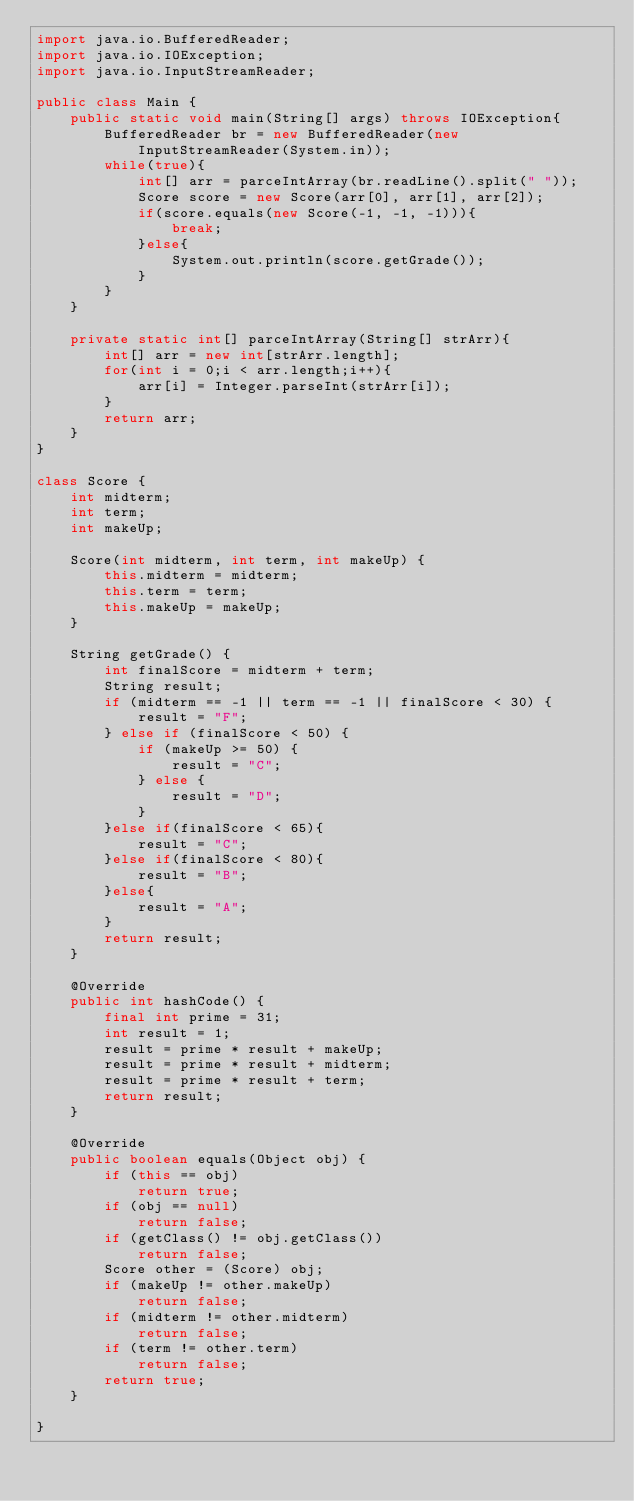<code> <loc_0><loc_0><loc_500><loc_500><_Java_>import java.io.BufferedReader;
import java.io.IOException;
import java.io.InputStreamReader;

public class Main {
	public static void main(String[] args) throws IOException{
		BufferedReader br = new BufferedReader(new InputStreamReader(System.in));
		while(true){
			int[] arr = parceIntArray(br.readLine().split(" "));
			Score score = new Score(arr[0], arr[1], arr[2]);
			if(score.equals(new Score(-1, -1, -1))){
				break;
			}else{
				System.out.println(score.getGrade());
			}
		}
	}
	
	private static int[] parceIntArray(String[] strArr){
		int[] arr = new int[strArr.length];
		for(int i = 0;i < arr.length;i++){
			arr[i] = Integer.parseInt(strArr[i]);
		}
		return arr;
	}
}

class Score {
	int midterm;
	int term;
	int makeUp;

	Score(int midterm, int term, int makeUp) {
		this.midterm = midterm;
		this.term = term;
		this.makeUp = makeUp;
	}

	String getGrade() {
		int finalScore = midterm + term;
		String result;
		if (midterm == -1 || term == -1 || finalScore < 30) {
			result = "F";
		} else if (finalScore < 50) {
			if (makeUp >= 50) {
				result = "C";
			} else {
				result = "D";
			}
		}else if(finalScore < 65){
			result = "C";
		}else if(finalScore < 80){
			result = "B";
		}else{
			result = "A";
		}
		return result;
	}

	@Override
	public int hashCode() {
		final int prime = 31;
		int result = 1;
		result = prime * result + makeUp;
		result = prime * result + midterm;
		result = prime * result + term;
		return result;
	}

	@Override
	public boolean equals(Object obj) {
		if (this == obj)
			return true;
		if (obj == null)
			return false;
		if (getClass() != obj.getClass())
			return false;
		Score other = (Score) obj;
		if (makeUp != other.makeUp)
			return false;
		if (midterm != other.midterm)
			return false;
		if (term != other.term)
			return false;
		return true;
	}
	
}</code> 